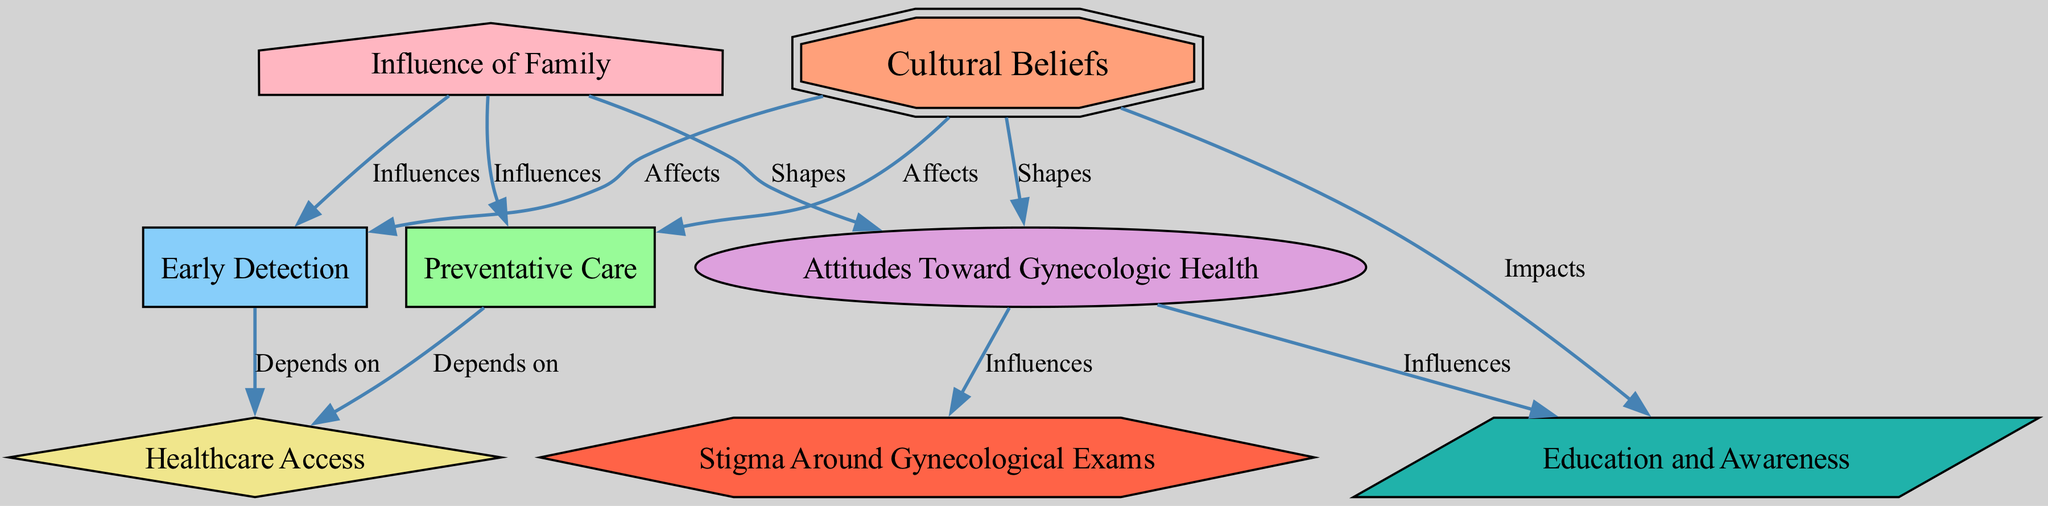What is the main factor that affects preventative care? The diagram shows an edge from "Cultural Beliefs" to "Preventative Care" labeled "Affects", indicating that cultural beliefs are the main factor influencing preventative care in this context.
Answer: Cultural Beliefs How many nodes are connected to the "Attitudes Toward Gynecologic Health"? By examining the edges connected to "Attitudes Toward Gynecologic Health", we can see that it is connected to three nodes: "Cultural Beliefs", "Stigma Around Gynecological Exams", and "Education and Awareness". Thus, it has three connections.
Answer: 3 Which node influences healthcare access? The diagram indicates that both "Preventative Care" and "Early Detection" have edges pointing to "Healthcare Access", showing that they depend on it. Therefore, both nodes influence healthcare access.
Answer: Preventative Care, Early Detection What shapes the attitudes toward gynecologic health? The diagram indicates that "Cultural Beliefs" and "Family Influence" both have edges directed towards "Attitudes Toward Gynecologic Health", each labeled "Shapes" and "Influences" respectively. Hence, both factors shape these attitudes.
Answer: Cultural Beliefs, Family Influence Which node impacts education and awareness? The diagram shows that "Cultural Beliefs" has an edge leading to "Education and Awareness" labeled "Impacts", explicitly indicating that it is the main factor that impacts education and awareness.
Answer: Cultural Beliefs What is the relationship between stigma around gynecological exams and attitudes towards gynecologic health? The edge from "Attitudes Toward Gynecologic Health" to "Stigma Around Gynecological Exams" is labeled "Influences", illustrating that attitudes towards gynecologic health influence stigma associated with gynecological exams.
Answer: Influences Which factor affects both preventative care and early detection? The diagram indicates that "Cultural Beliefs" affects both "Preventative Care" and "Early Detection" through edges labeled "Affects". Therefore, they are both influenced by this factor.
Answer: Cultural Beliefs How does family influence the attitudes towards gynecologic health? The diagram suggests that “Family Influence” shapes “Attitudes Toward Gynecologic Health” as shown by the directed edge labeled “Shapes” linking the two nodes. This indicates a direct relationship where family influence molds these attitudes.
Answer: Shapes How many total edges are present in the diagram? Counting all the edges listed in the diagram, we identify that there are a total of ten directed connections between the nodes represented, totaling to ten edges.
Answer: 10 